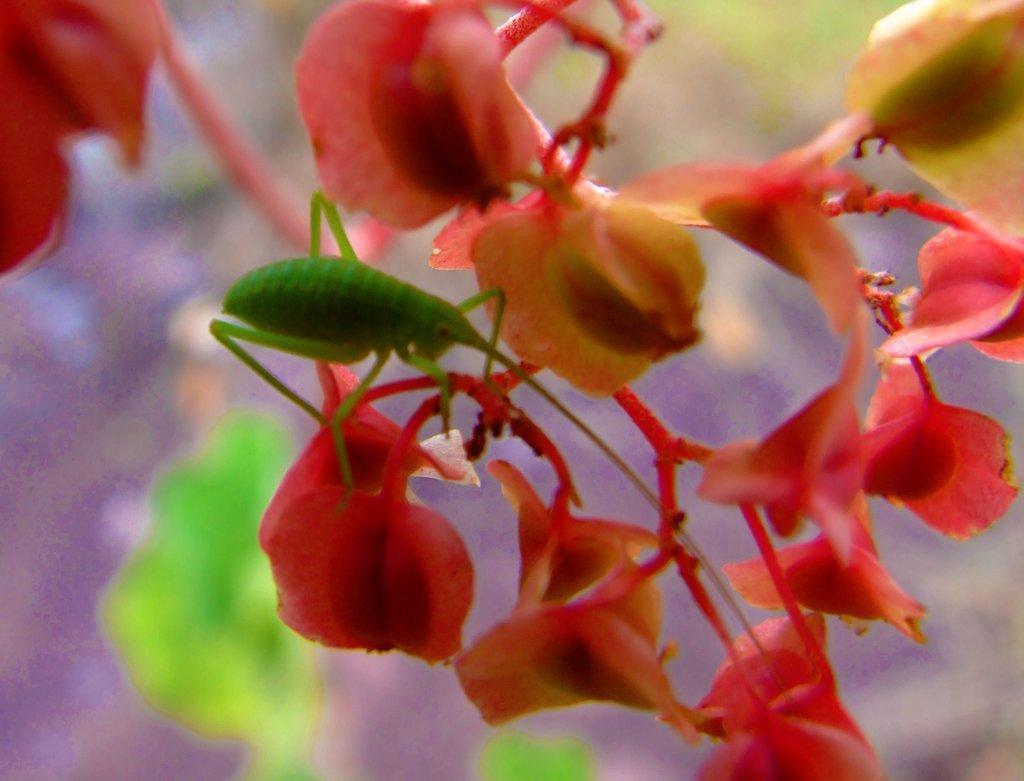In one or two sentences, can you explain what this image depicts? In this picture we can see an insect, flowers. In the background, the image is blurred. 